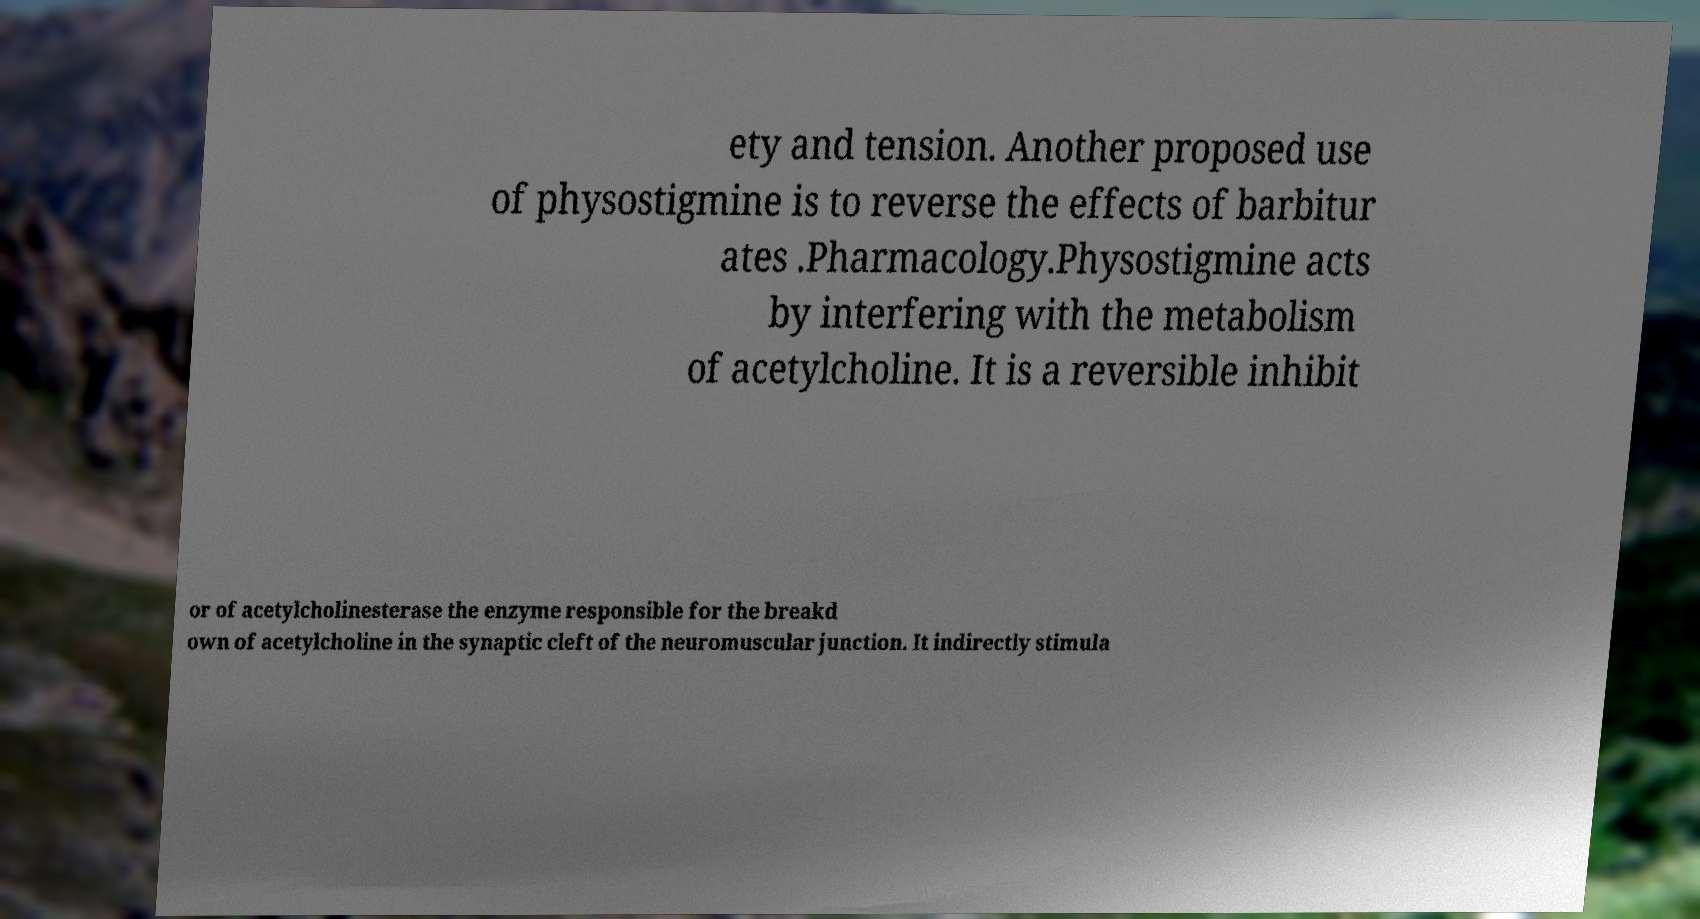Can you read and provide the text displayed in the image?This photo seems to have some interesting text. Can you extract and type it out for me? ety and tension. Another proposed use of physostigmine is to reverse the effects of barbitur ates .Pharmacology.Physostigmine acts by interfering with the metabolism of acetylcholine. It is a reversible inhibit or of acetylcholinesterase the enzyme responsible for the breakd own of acetylcholine in the synaptic cleft of the neuromuscular junction. It indirectly stimula 